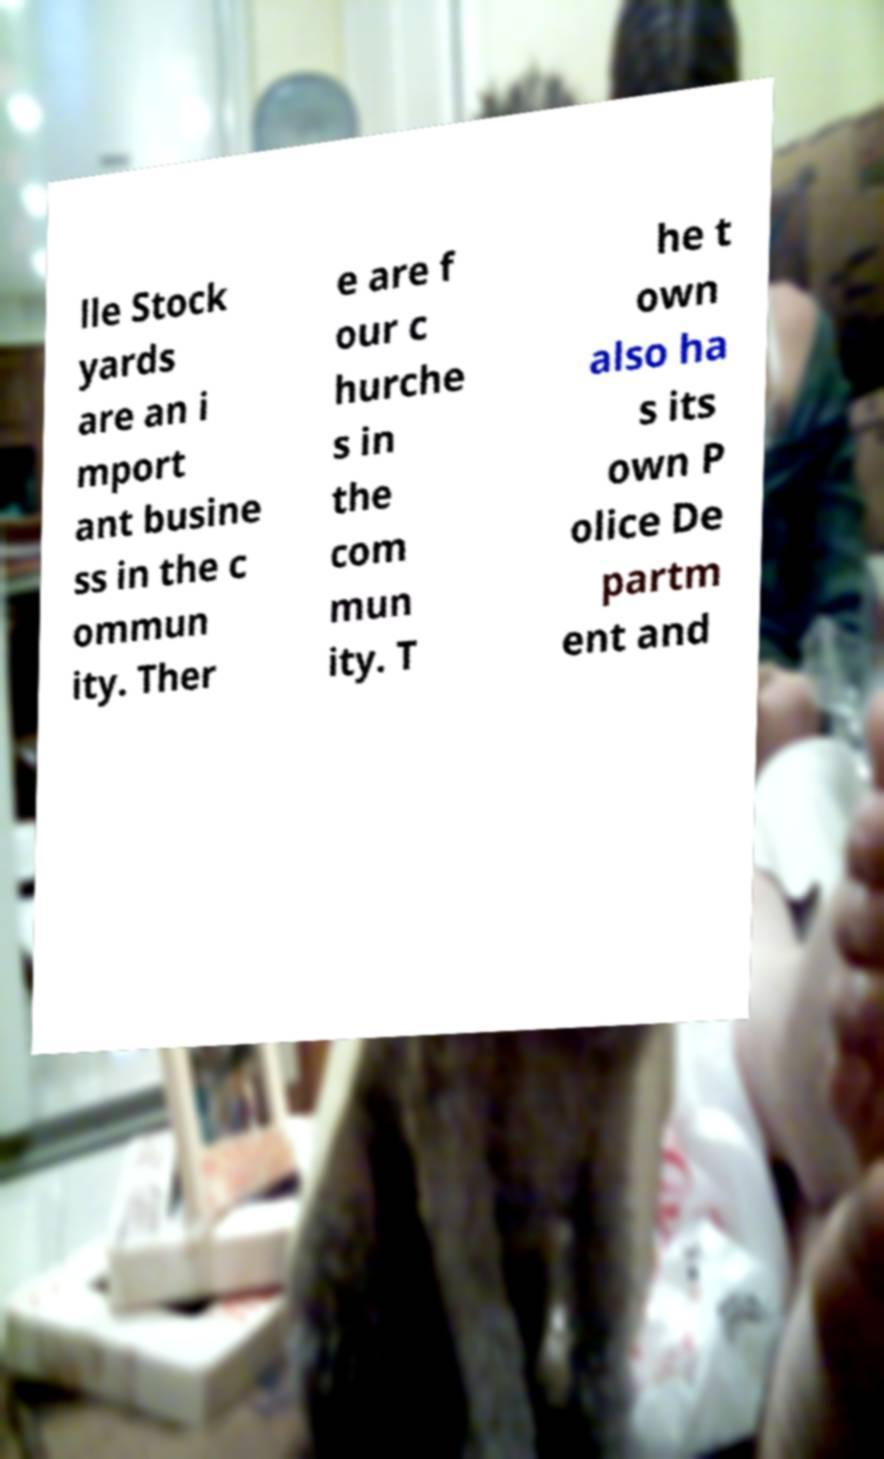Could you assist in decoding the text presented in this image and type it out clearly? lle Stock yards are an i mport ant busine ss in the c ommun ity. Ther e are f our c hurche s in the com mun ity. T he t own also ha s its own P olice De partm ent and 